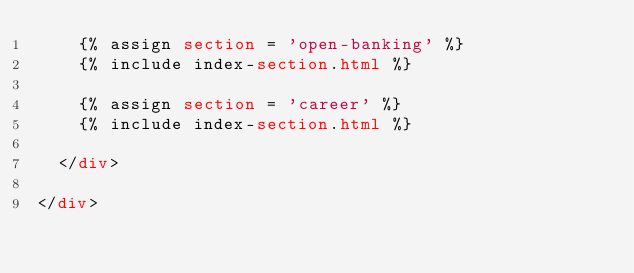<code> <loc_0><loc_0><loc_500><loc_500><_HTML_>    {% assign section = 'open-banking' %}
    {% include index-section.html %}
        
    {% assign section = 'career' %}
    {% include index-section.html %}
  
  </div>

</div>
</code> 